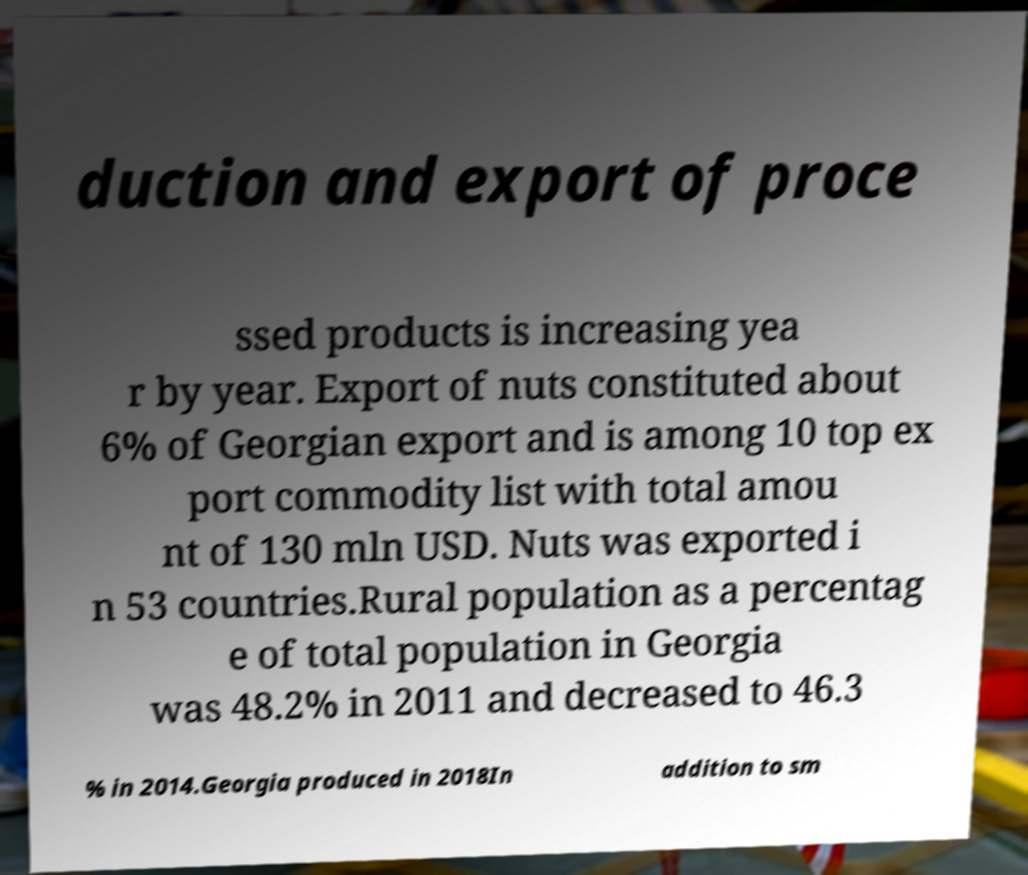Could you extract and type out the text from this image? duction and export of proce ssed products is increasing yea r by year. Export of nuts constituted about 6% of Georgian export and is among 10 top ex port commodity list with total amou nt of 130 mln USD. Nuts was exported i n 53 countries.Rural population as a percentag e of total population in Georgia was 48.2% in 2011 and decreased to 46.3 % in 2014.Georgia produced in 2018In addition to sm 